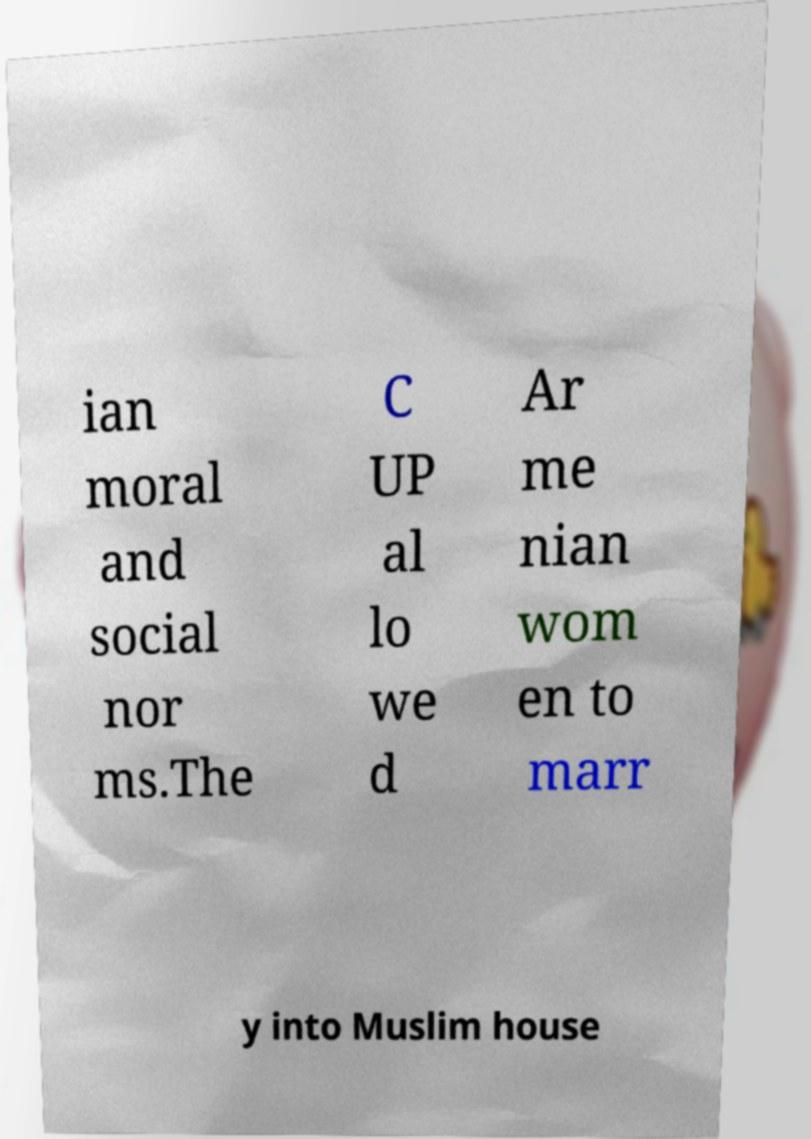Can you accurately transcribe the text from the provided image for me? ian moral and social nor ms.The C UP al lo we d Ar me nian wom en to marr y into Muslim house 